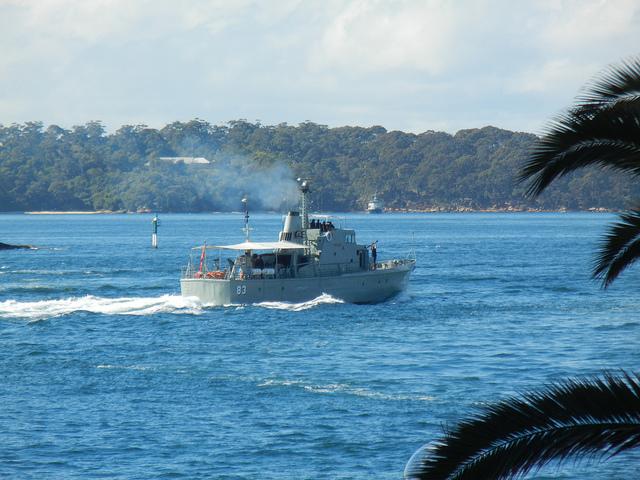Is this water clean looking?
Keep it brief. Yes. What is the tree on the right?
Keep it brief. Palm. Is there smoke coming from the boat?
Short answer required. Yes. 